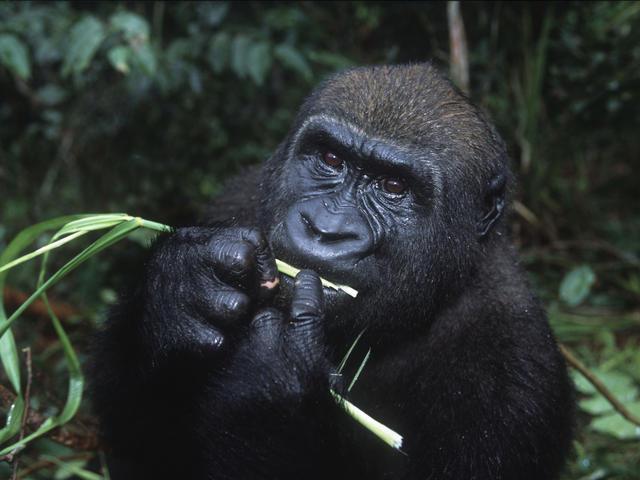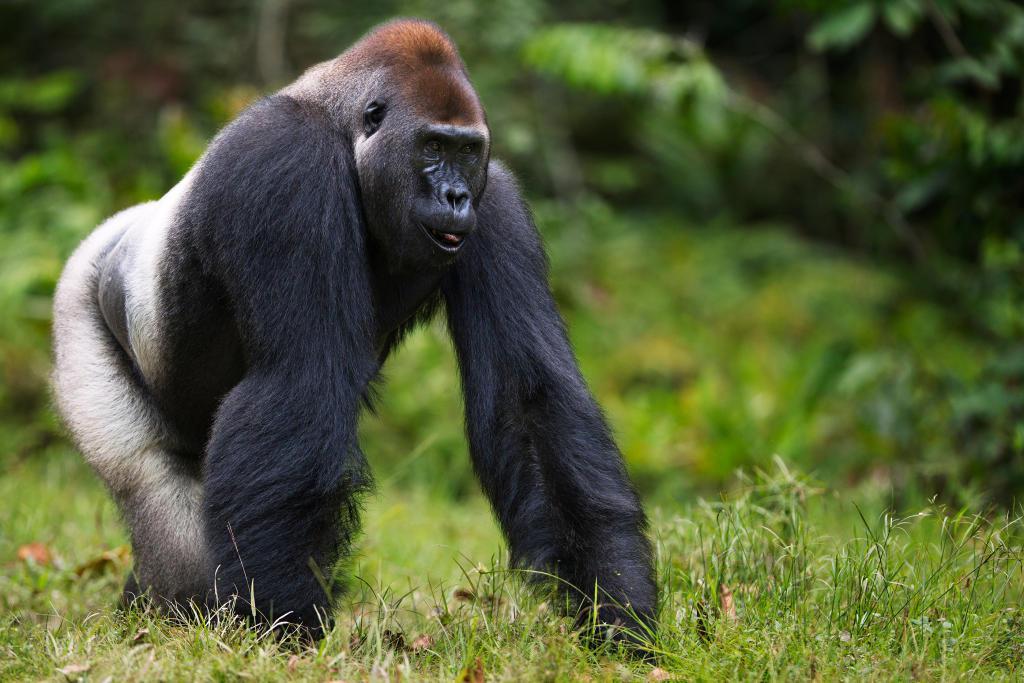The first image is the image on the left, the second image is the image on the right. Assess this claim about the two images: "An image shows a baby gorilla held in its mother's arms.". Correct or not? Answer yes or no. No. The first image is the image on the left, the second image is the image on the right. Given the left and right images, does the statement "A gorilla is holding a baby in one of the images." hold true? Answer yes or no. No. 